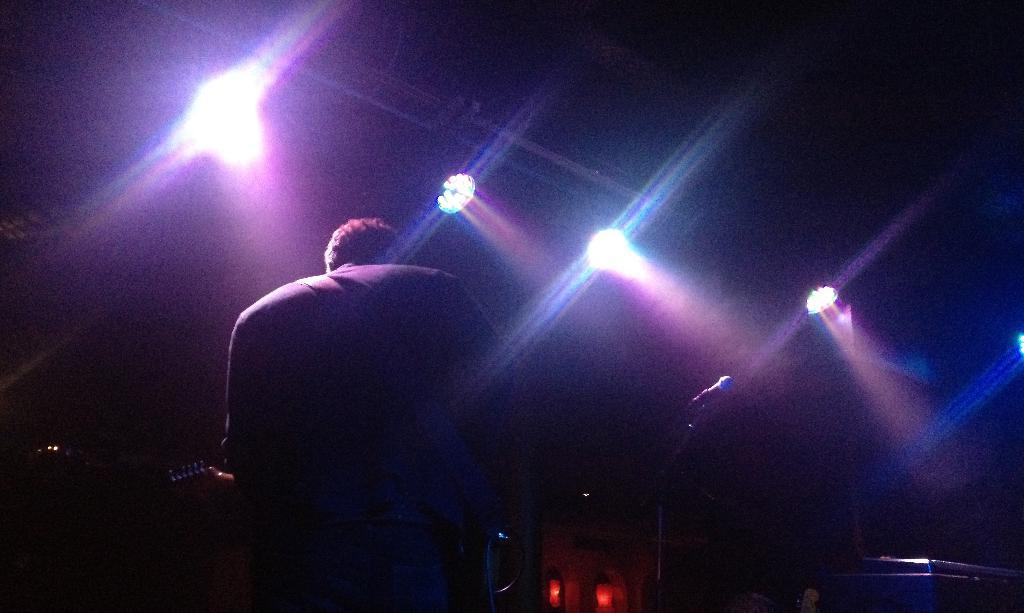What is the man in the image doing? The man is standing in the image and holding a musical instrument. What can be seen near the man in the image? There is a microphone with a stand in the image. What is on the table in the image? There is a device on a table in the image. What can be seen in the background of the image? There are lights visible in the image. What type of gun is the man using to play the musical instrument in the image? There is no gun present in the image; the man is holding a musical instrument. What is the height of the cork visible in the image? There is no cork present in the image. 